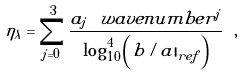Convert formula to latex. <formula><loc_0><loc_0><loc_500><loc_500>\eta _ { \lambda } = \sum _ { j = 0 } ^ { 3 } \frac { a _ { j } \, \ w a v e n u m b e r ^ { j } } { \log ^ { 4 } _ { 1 0 } \left ( { b / a | } _ { r e f } \right ) } \ ,</formula> 